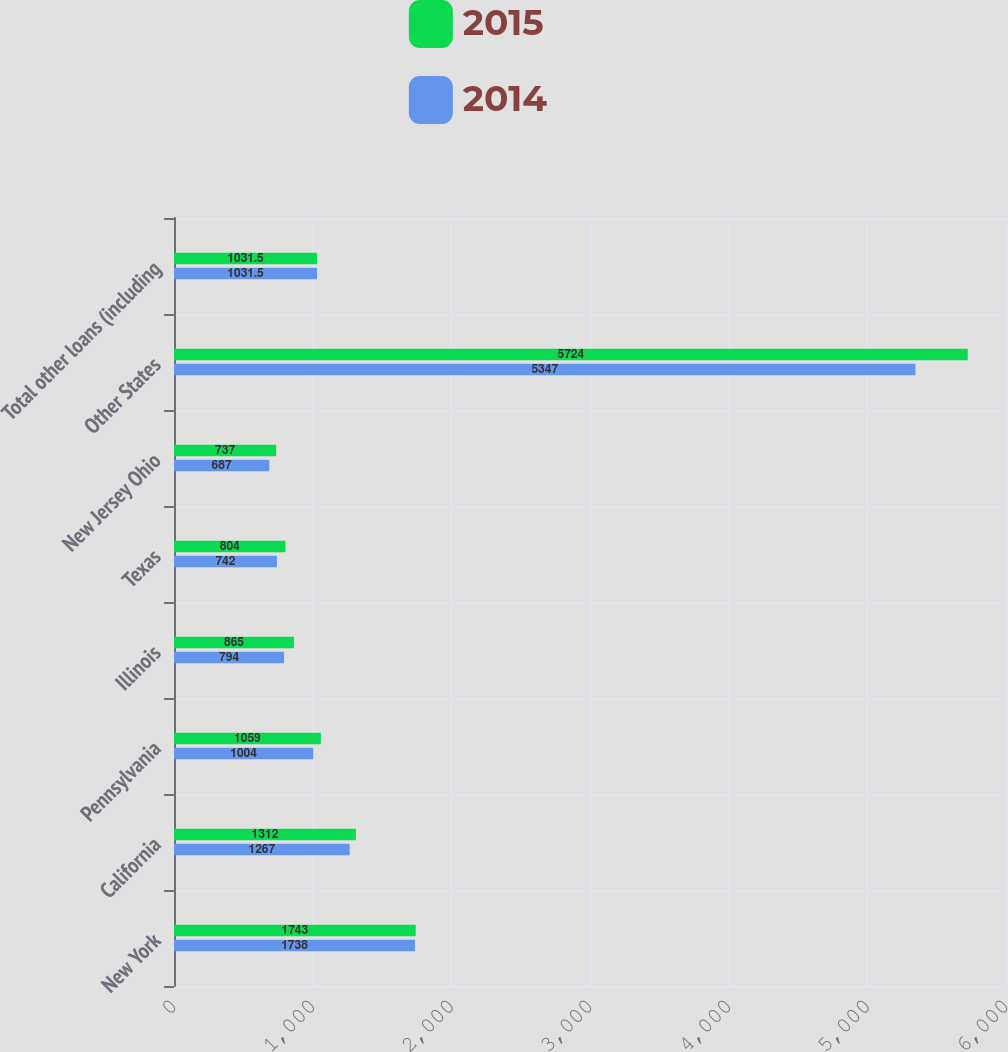<chart> <loc_0><loc_0><loc_500><loc_500><stacked_bar_chart><ecel><fcel>New York<fcel>California<fcel>Pennsylvania<fcel>Illinois<fcel>Texas<fcel>New Jersey Ohio<fcel>Other States<fcel>Total other loans (including<nl><fcel>2015<fcel>1743<fcel>1312<fcel>1059<fcel>865<fcel>804<fcel>737<fcel>5724<fcel>1031.5<nl><fcel>2014<fcel>1738<fcel>1267<fcel>1004<fcel>794<fcel>742<fcel>687<fcel>5347<fcel>1031.5<nl></chart> 